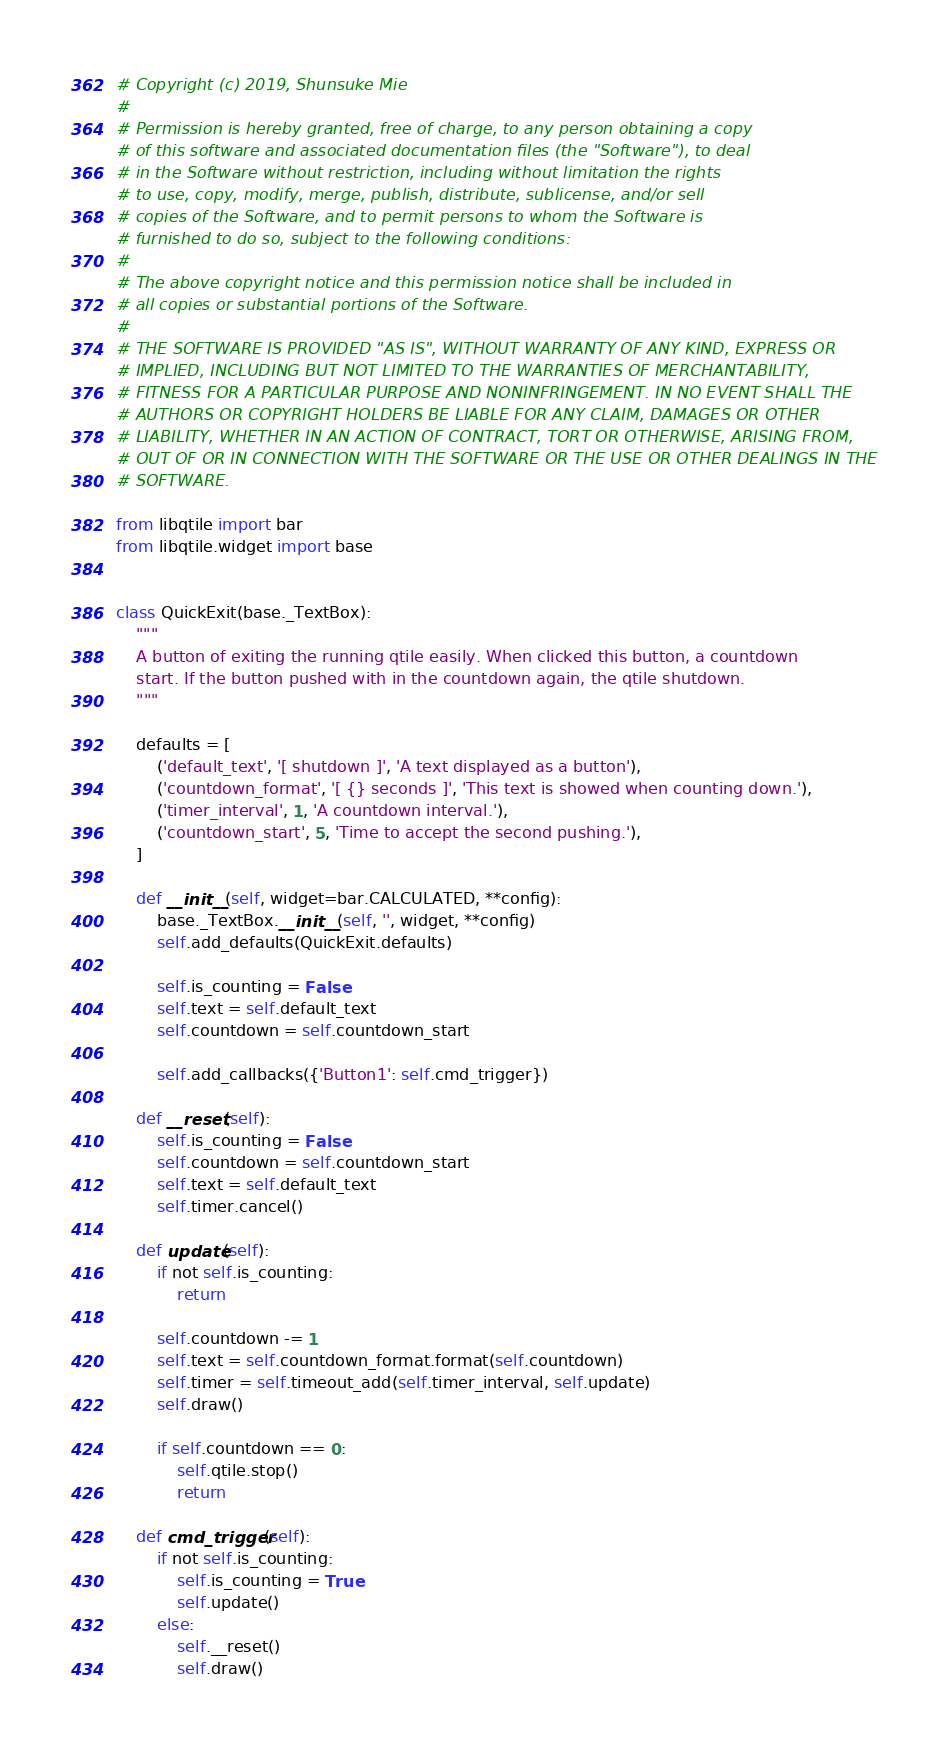<code> <loc_0><loc_0><loc_500><loc_500><_Python_># Copyright (c) 2019, Shunsuke Mie
#
# Permission is hereby granted, free of charge, to any person obtaining a copy
# of this software and associated documentation files (the "Software"), to deal
# in the Software without restriction, including without limitation the rights
# to use, copy, modify, merge, publish, distribute, sublicense, and/or sell
# copies of the Software, and to permit persons to whom the Software is
# furnished to do so, subject to the following conditions:
#
# The above copyright notice and this permission notice shall be included in
# all copies or substantial portions of the Software.
#
# THE SOFTWARE IS PROVIDED "AS IS", WITHOUT WARRANTY OF ANY KIND, EXPRESS OR
# IMPLIED, INCLUDING BUT NOT LIMITED TO THE WARRANTIES OF MERCHANTABILITY,
# FITNESS FOR A PARTICULAR PURPOSE AND NONINFRINGEMENT. IN NO EVENT SHALL THE
# AUTHORS OR COPYRIGHT HOLDERS BE LIABLE FOR ANY CLAIM, DAMAGES OR OTHER
# LIABILITY, WHETHER IN AN ACTION OF CONTRACT, TORT OR OTHERWISE, ARISING FROM,
# OUT OF OR IN CONNECTION WITH THE SOFTWARE OR THE USE OR OTHER DEALINGS IN THE
# SOFTWARE.

from libqtile import bar
from libqtile.widget import base


class QuickExit(base._TextBox):
    """
    A button of exiting the running qtile easily. When clicked this button, a countdown
    start. If the button pushed with in the countdown again, the qtile shutdown.
    """

    defaults = [
        ('default_text', '[ shutdown ]', 'A text displayed as a button'),
        ('countdown_format', '[ {} seconds ]', 'This text is showed when counting down.'),
        ('timer_interval', 1, 'A countdown interval.'),
        ('countdown_start', 5, 'Time to accept the second pushing.'),
    ]

    def __init__(self, widget=bar.CALCULATED, **config):
        base._TextBox.__init__(self, '', widget, **config)
        self.add_defaults(QuickExit.defaults)

        self.is_counting = False
        self.text = self.default_text
        self.countdown = self.countdown_start

        self.add_callbacks({'Button1': self.cmd_trigger})

    def __reset(self):
        self.is_counting = False
        self.countdown = self.countdown_start
        self.text = self.default_text
        self.timer.cancel()

    def update(self):
        if not self.is_counting:
            return

        self.countdown -= 1
        self.text = self.countdown_format.format(self.countdown)
        self.timer = self.timeout_add(self.timer_interval, self.update)
        self.draw()

        if self.countdown == 0:
            self.qtile.stop()
            return

    def cmd_trigger(self):
        if not self.is_counting:
            self.is_counting = True
            self.update()
        else:
            self.__reset()
            self.draw()
</code> 